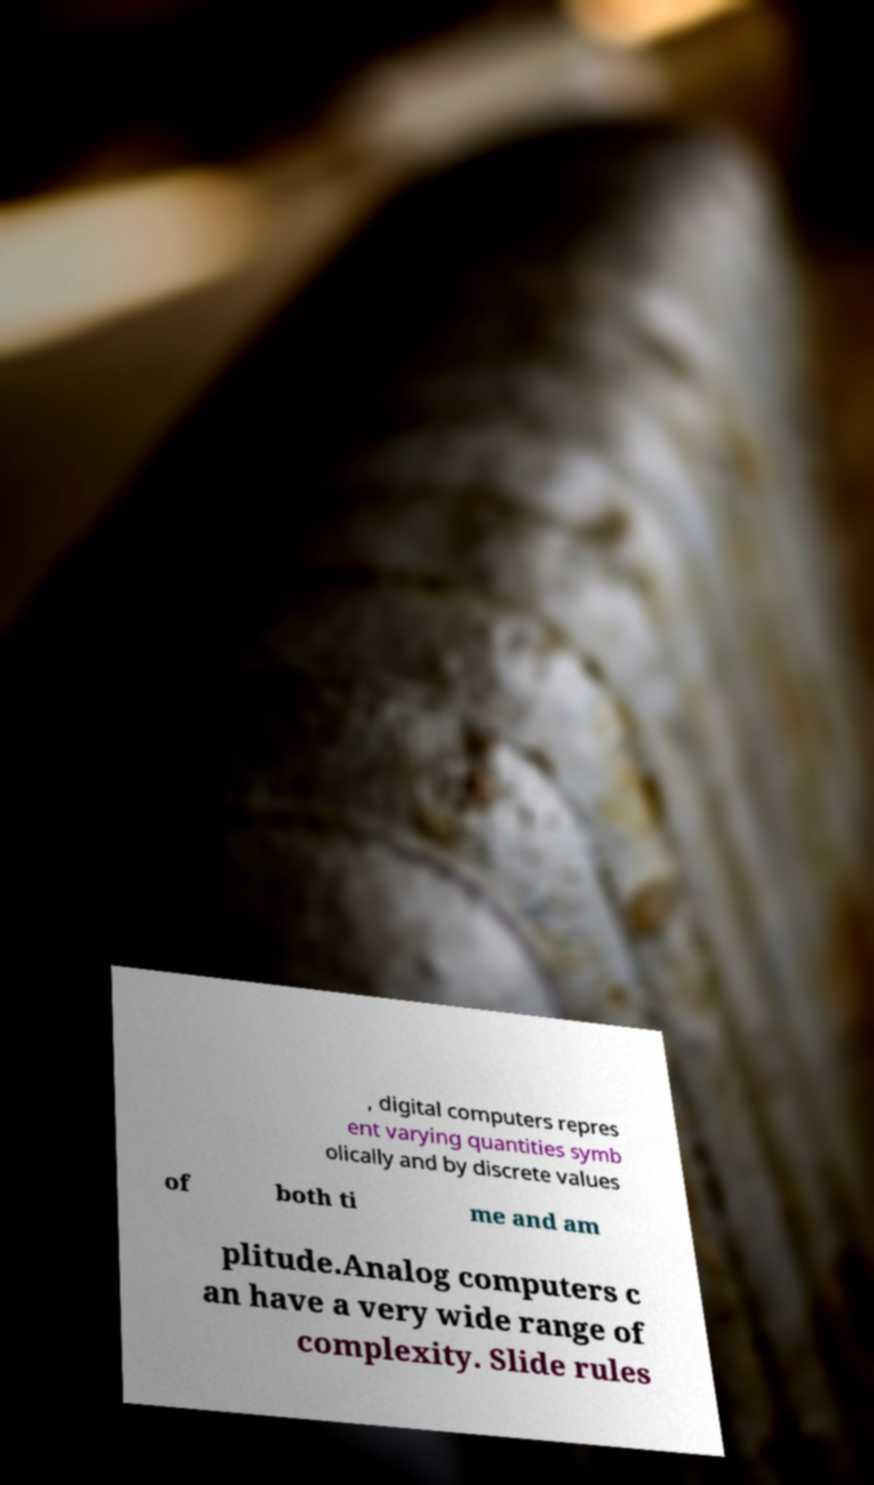What messages or text are displayed in this image? I need them in a readable, typed format. , digital computers repres ent varying quantities symb olically and by discrete values of both ti me and am plitude.Analog computers c an have a very wide range of complexity. Slide rules 